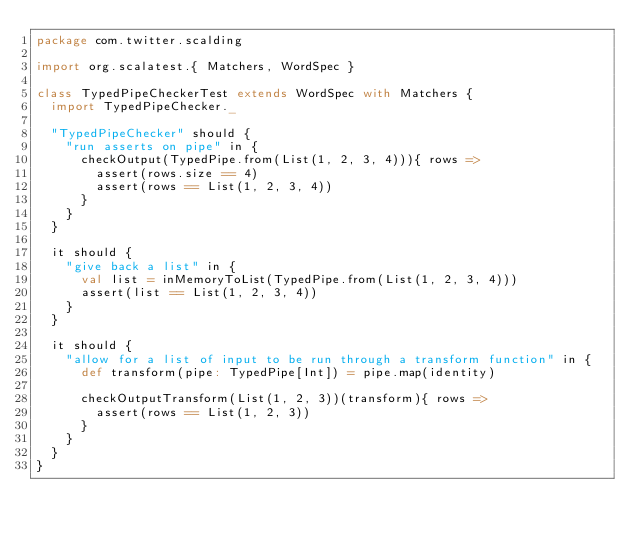Convert code to text. <code><loc_0><loc_0><loc_500><loc_500><_Scala_>package com.twitter.scalding

import org.scalatest.{ Matchers, WordSpec }

class TypedPipeCheckerTest extends WordSpec with Matchers {
  import TypedPipeChecker._

  "TypedPipeChecker" should {
    "run asserts on pipe" in {
      checkOutput(TypedPipe.from(List(1, 2, 3, 4))){ rows =>
        assert(rows.size == 4)
        assert(rows == List(1, 2, 3, 4))
      }
    }
  }

  it should {
    "give back a list" in {
      val list = inMemoryToList(TypedPipe.from(List(1, 2, 3, 4)))
      assert(list == List(1, 2, 3, 4))
    }
  }

  it should {
    "allow for a list of input to be run through a transform function" in {
      def transform(pipe: TypedPipe[Int]) = pipe.map(identity)

      checkOutputTransform(List(1, 2, 3))(transform){ rows =>
        assert(rows == List(1, 2, 3))
      }
    }
  }
}
</code> 